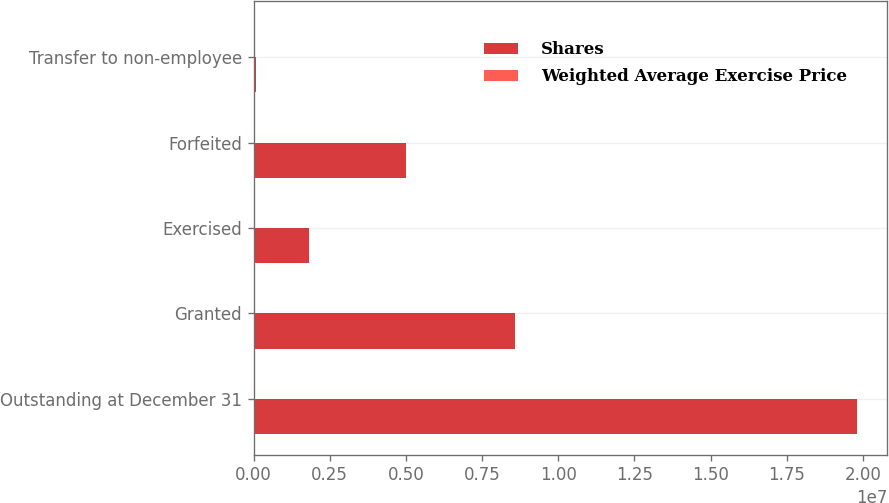Convert chart. <chart><loc_0><loc_0><loc_500><loc_500><stacked_bar_chart><ecel><fcel>Outstanding at December 31<fcel>Granted<fcel>Exercised<fcel>Forfeited<fcel>Transfer to non-employee<nl><fcel>Shares<fcel>1.98065e+07<fcel>8.5757e+06<fcel>1.81824e+06<fcel>5.00986e+06<fcel>77586<nl><fcel>Weighted Average Exercise Price<fcel>38.82<fcel>29.66<fcel>28.6<fcel>29.4<fcel>27.55<nl></chart> 